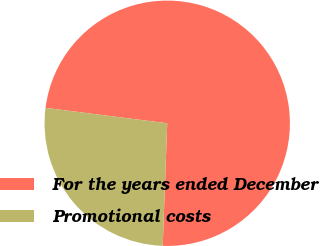Convert chart. <chart><loc_0><loc_0><loc_500><loc_500><pie_chart><fcel>For the years ended December<fcel>Promotional costs<nl><fcel>73.58%<fcel>26.42%<nl></chart> 